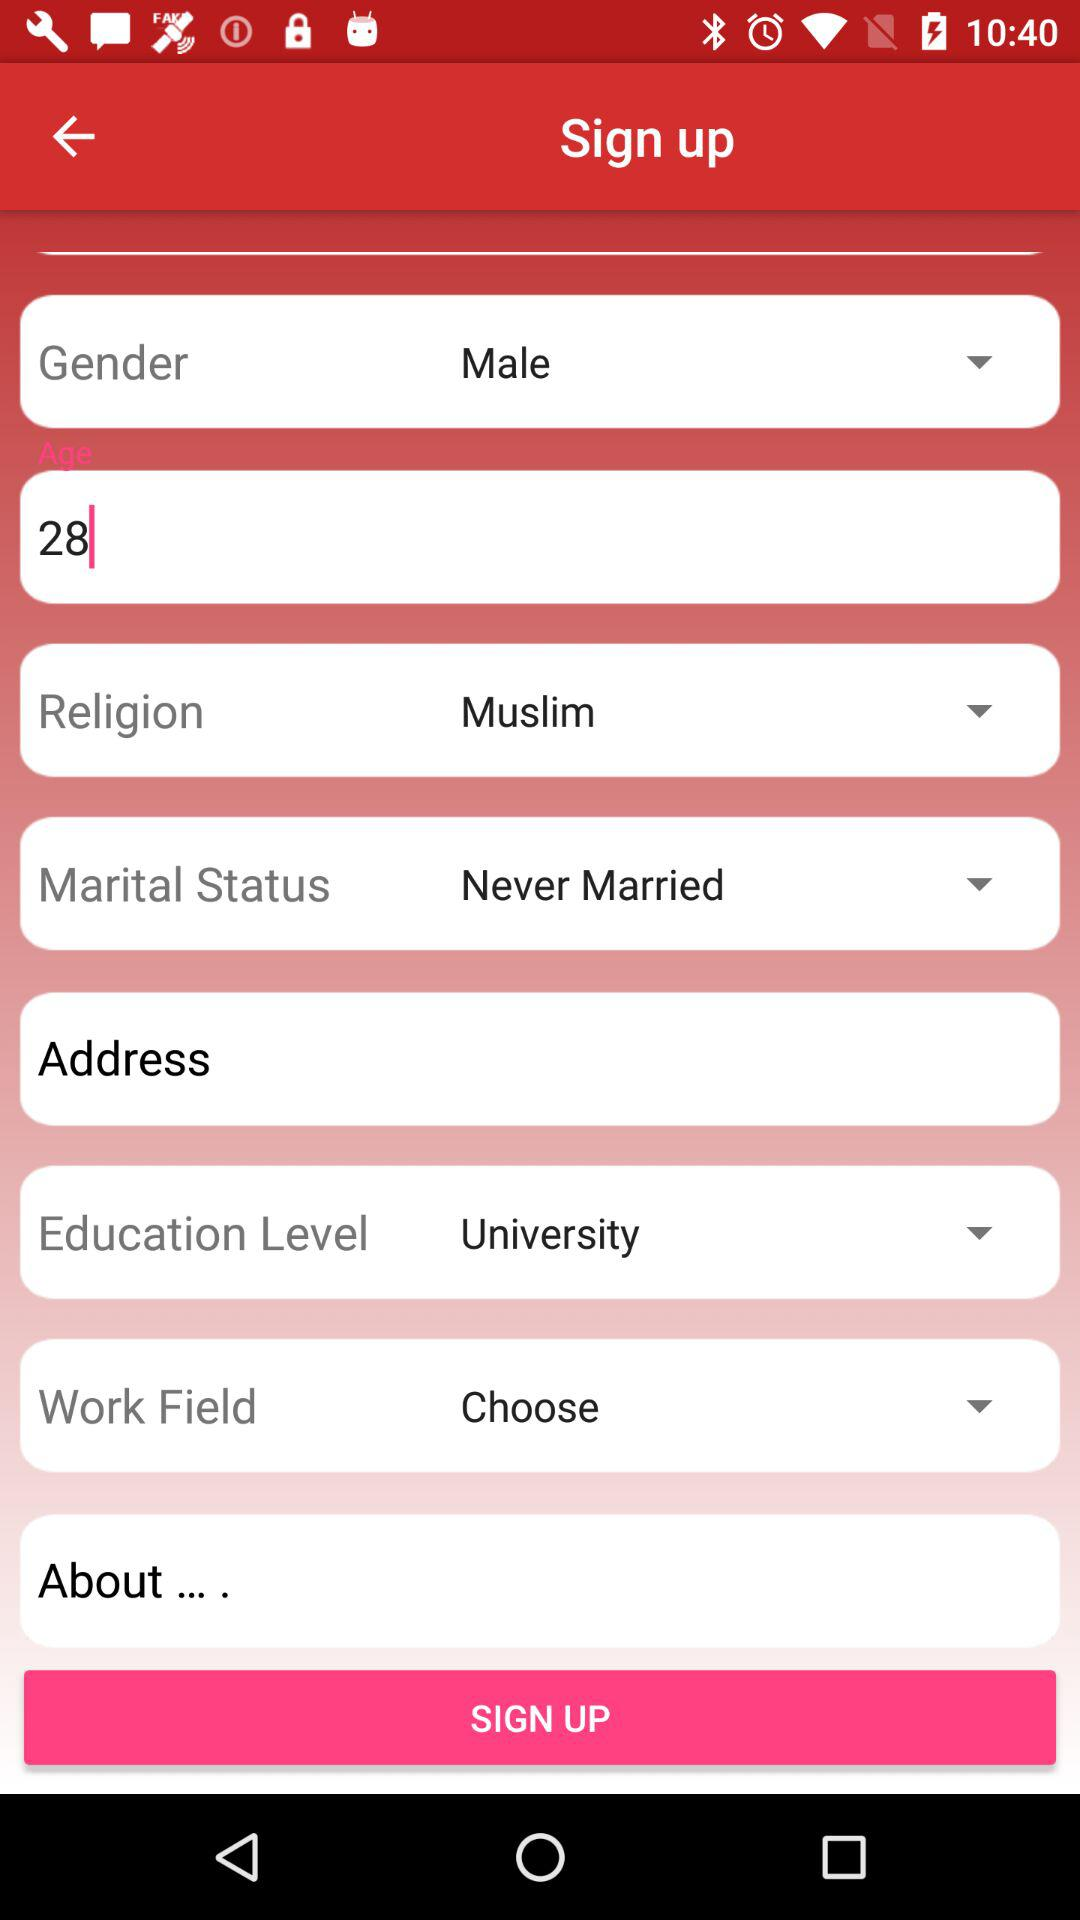What is the marital status of the user? The marital status is "Never Married". 